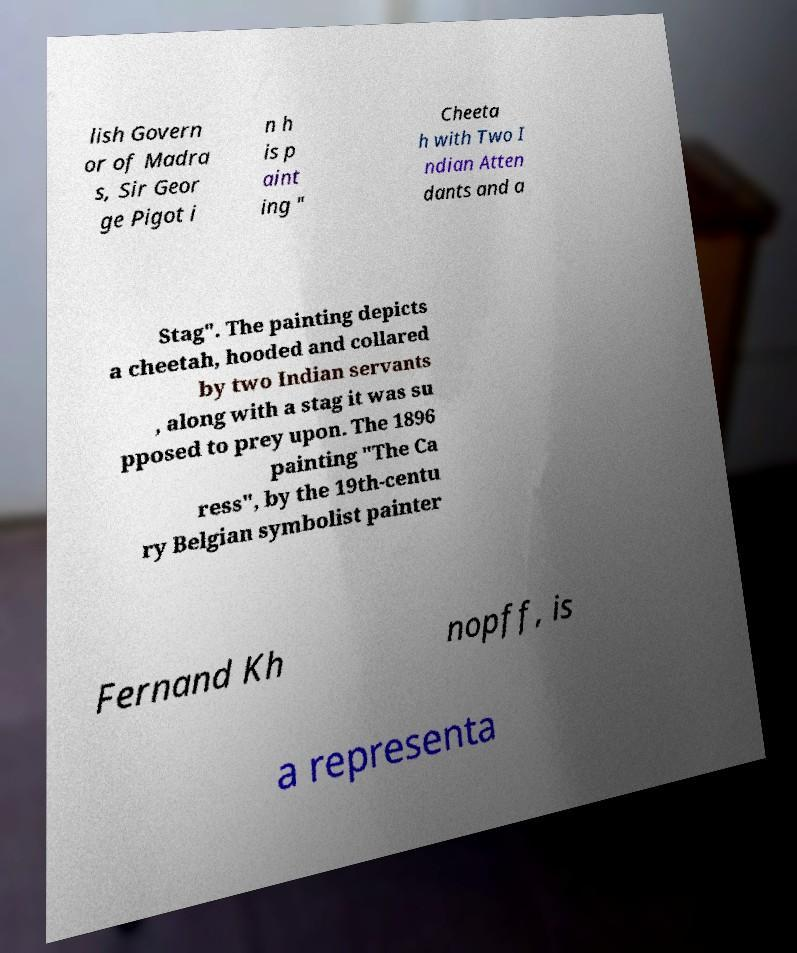Please read and relay the text visible in this image. What does it say? lish Govern or of Madra s, Sir Geor ge Pigot i n h is p aint ing " Cheeta h with Two I ndian Atten dants and a Stag". The painting depicts a cheetah, hooded and collared by two Indian servants , along with a stag it was su pposed to prey upon. The 1896 painting "The Ca ress", by the 19th-centu ry Belgian symbolist painter Fernand Kh nopff, is a representa 